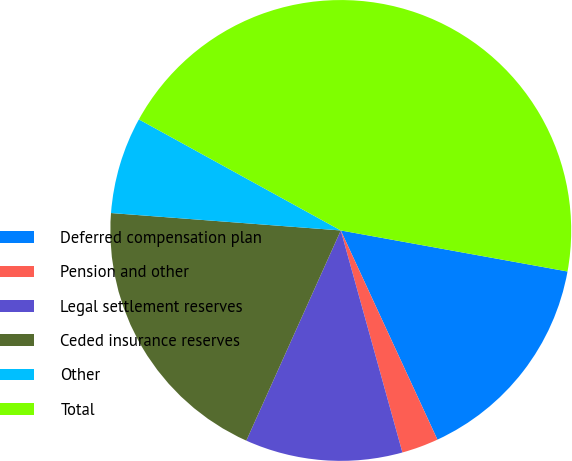Convert chart to OTSL. <chart><loc_0><loc_0><loc_500><loc_500><pie_chart><fcel>Deferred compensation plan<fcel>Pension and other<fcel>Legal settlement reserves<fcel>Ceded insurance reserves<fcel>Other<fcel>Total<nl><fcel>15.26%<fcel>2.58%<fcel>11.03%<fcel>19.48%<fcel>6.8%<fcel>44.84%<nl></chart> 